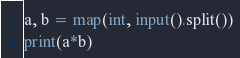Convert code to text. <code><loc_0><loc_0><loc_500><loc_500><_Python_>a, b = map(int, input().split())
print(a*b)</code> 